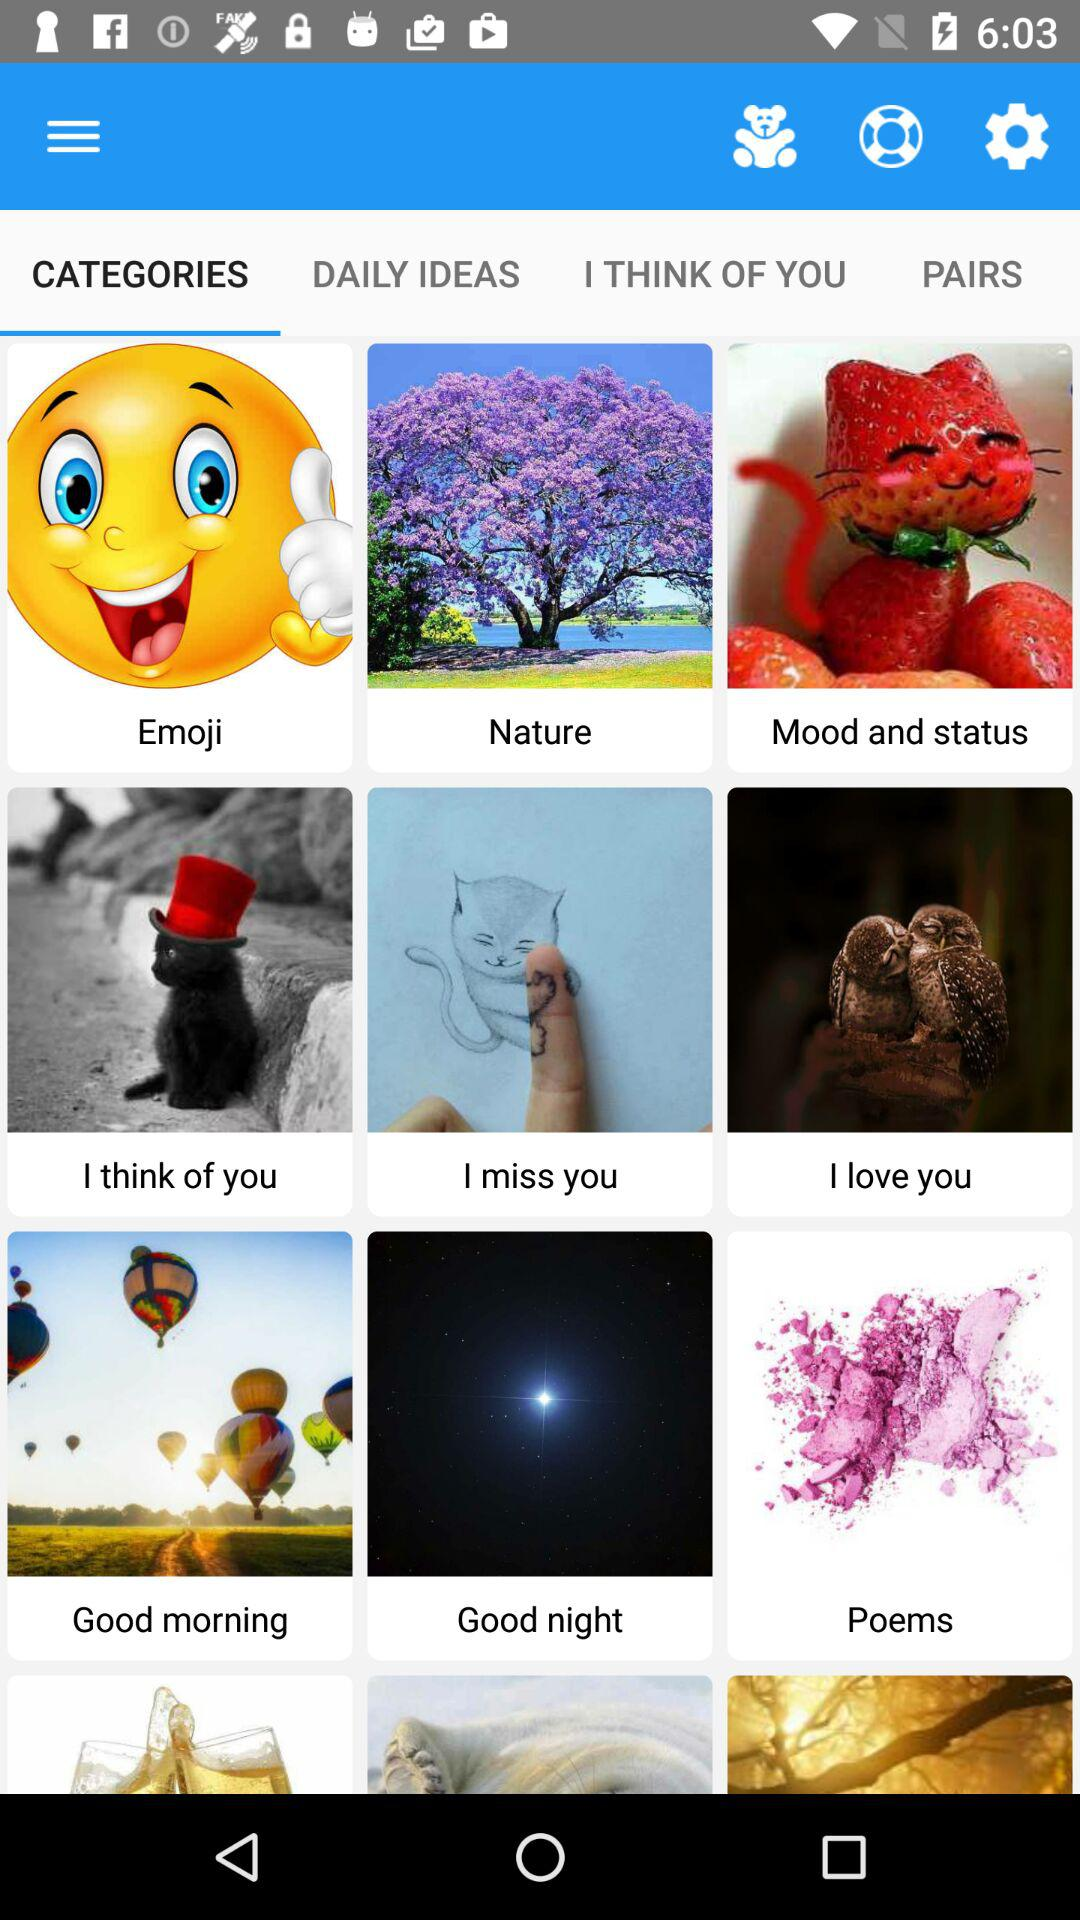Which tab is selected? The selected tab is "CATEGORIES". 